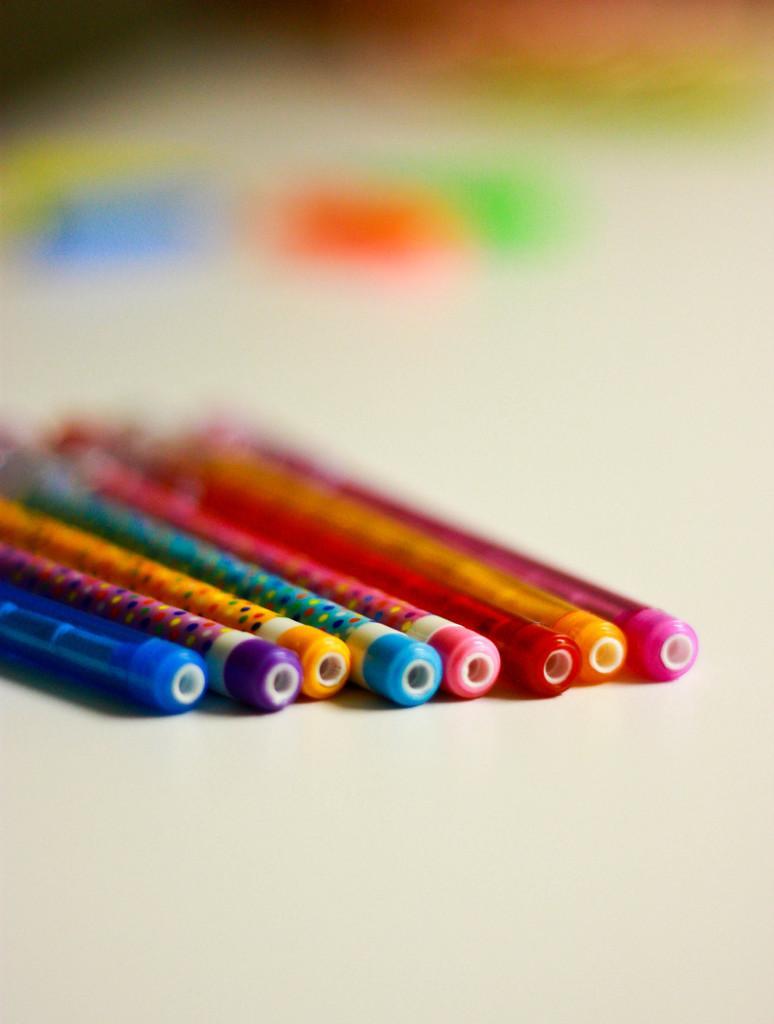Could you give a brief overview of what you see in this image? The picture consist of pen pencils of different colors. The background is blurred. 